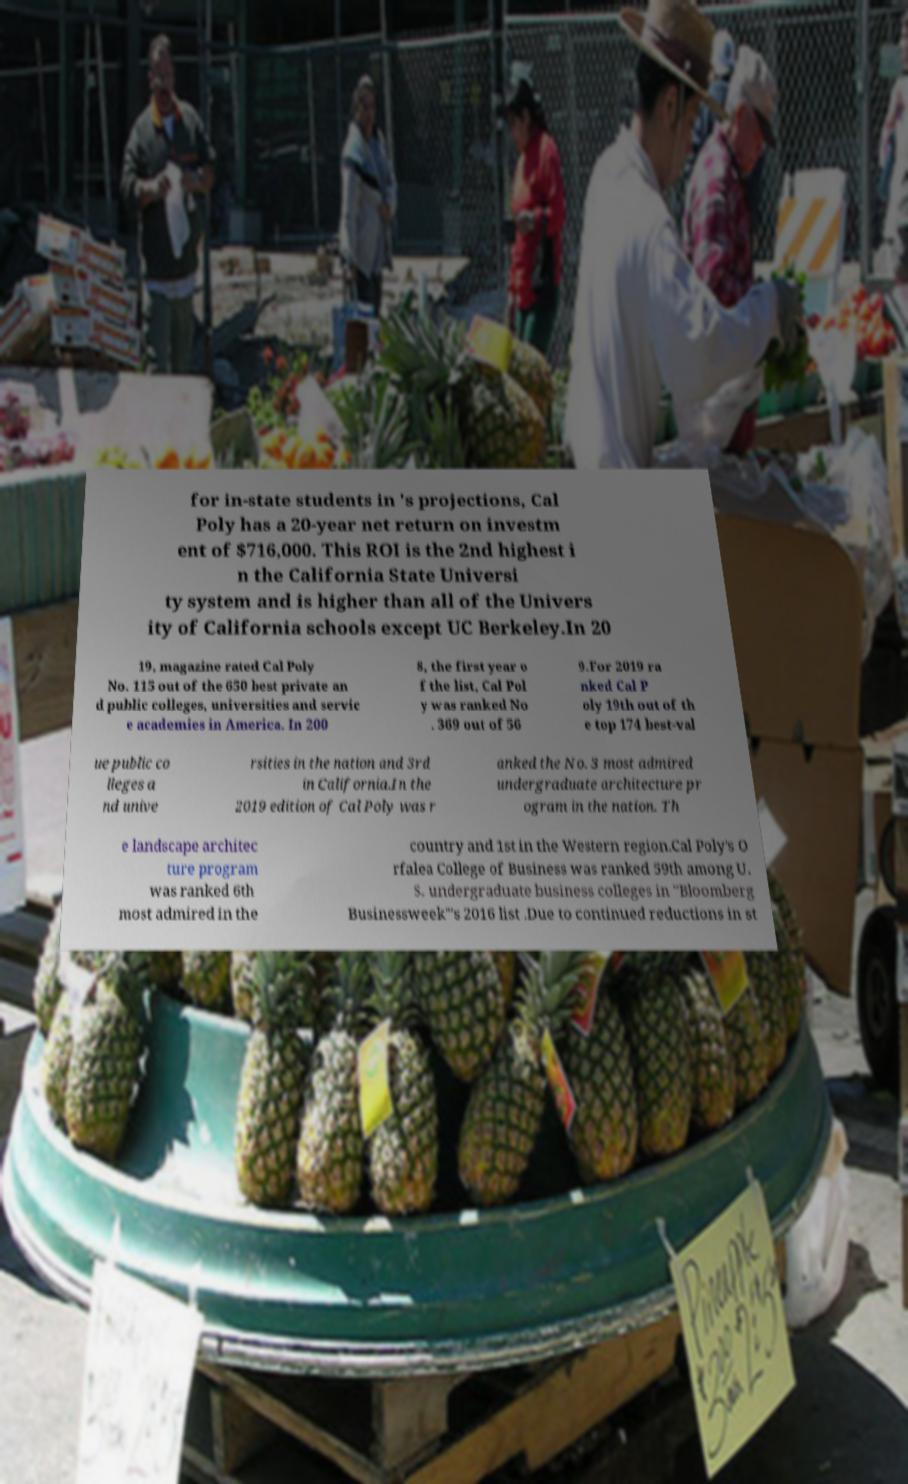Please read and relay the text visible in this image. What does it say? for in-state students in 's projections, Cal Poly has a 20-year net return on investm ent of $716,000. This ROI is the 2nd highest i n the California State Universi ty system and is higher than all of the Univers ity of California schools except UC Berkeley.In 20 19, magazine rated Cal Poly No. 115 out of the 650 best private an d public colleges, universities and servic e academies in America. In 200 8, the first year o f the list, Cal Pol y was ranked No . 369 out of 56 9.For 2019 ra nked Cal P oly 19th out of th e top 174 best-val ue public co lleges a nd unive rsities in the nation and 3rd in California.In the 2019 edition of Cal Poly was r anked the No. 3 most admired undergraduate architecture pr ogram in the nation. Th e landscape architec ture program was ranked 6th most admired in the country and 1st in the Western region.Cal Poly's O rfalea College of Business was ranked 59th among U. S. undergraduate business colleges in "Bloomberg Businessweek"'s 2016 list .Due to continued reductions in st 